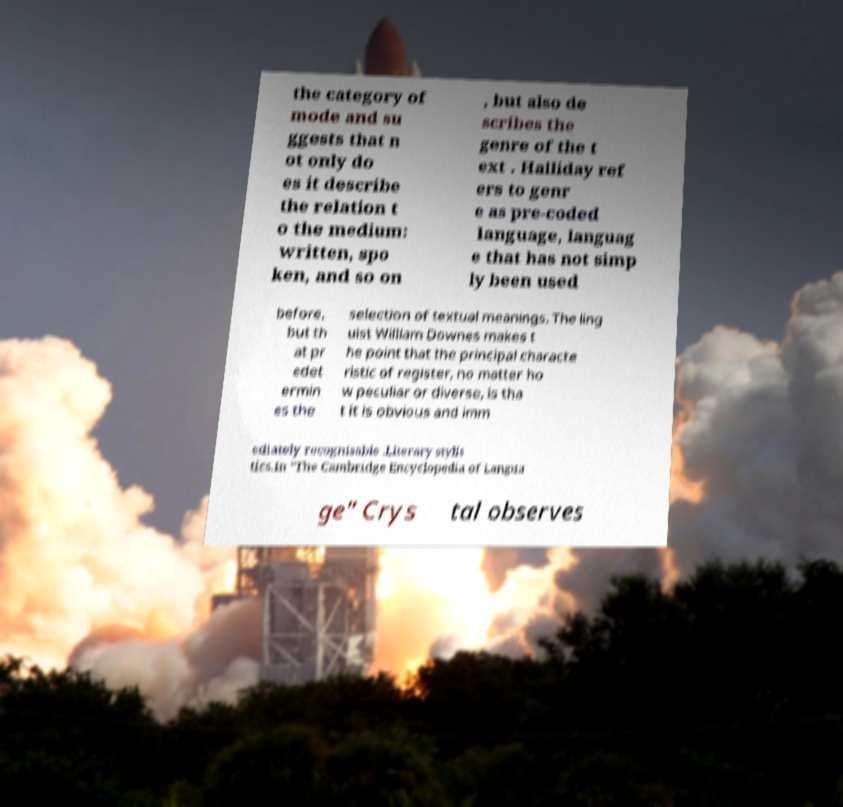I need the written content from this picture converted into text. Can you do that? the category of mode and su ggests that n ot only do es it describe the relation t o the medium: written, spo ken, and so on , but also de scribes the genre of the t ext . Halliday ref ers to genr e as pre-coded language, languag e that has not simp ly been used before, but th at pr edet ermin es the selection of textual meanings. The ling uist William Downes makes t he point that the principal characte ristic of register, no matter ho w peculiar or diverse, is tha t it is obvious and imm ediately recognisable .Literary stylis tics.In "The Cambridge Encyclopedia of Langua ge" Crys tal observes 